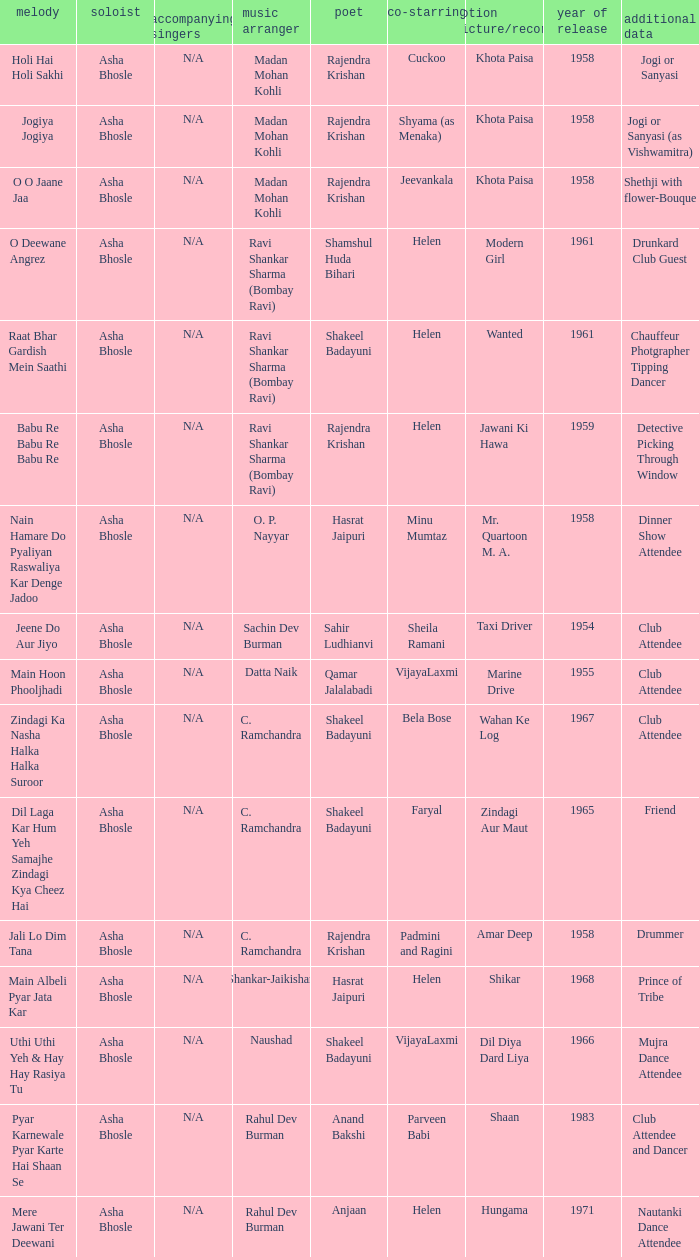In which film did vijayalaxmi co-star and shakeel badayuni pen the lyrics? Dil Diya Dard Liya. 